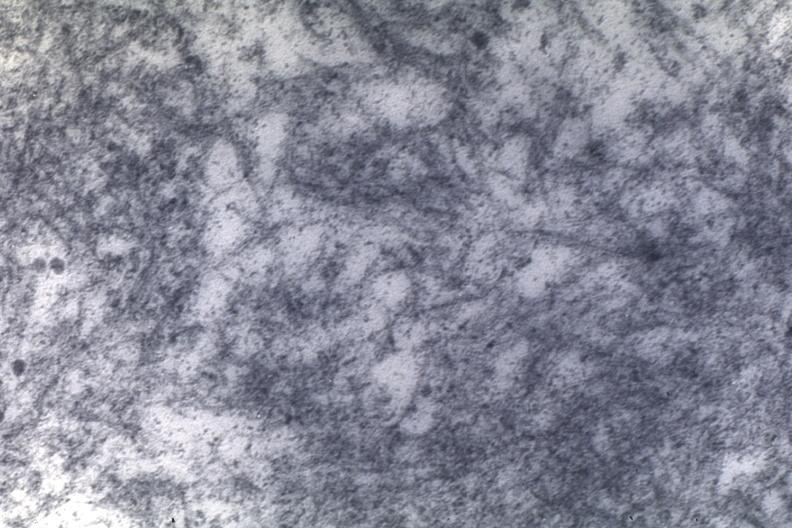s papillary intraductal adenocarcinoma present?
Answer the question using a single word or phrase. No 